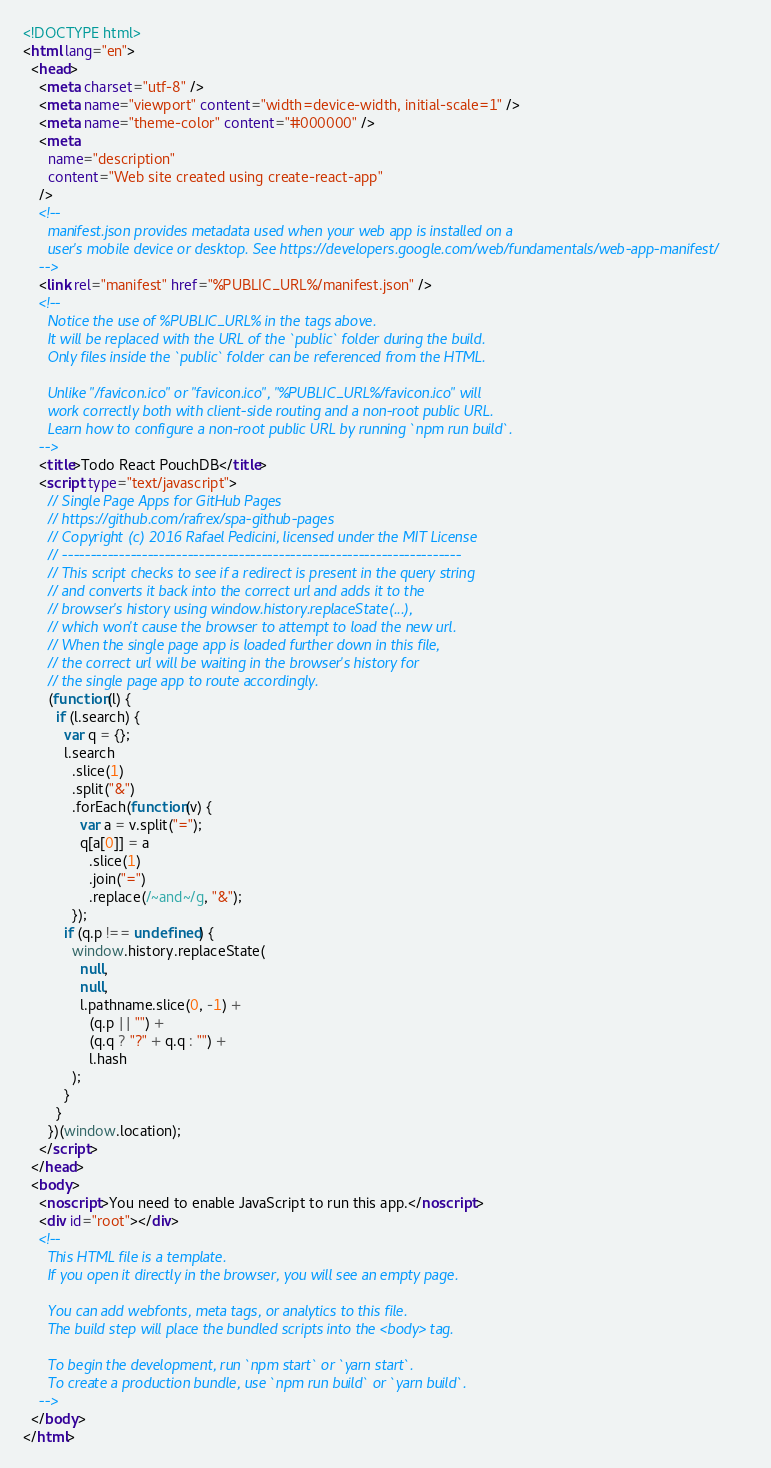Convert code to text. <code><loc_0><loc_0><loc_500><loc_500><_HTML_><!DOCTYPE html>
<html lang="en">
  <head>
    <meta charset="utf-8" />
    <meta name="viewport" content="width=device-width, initial-scale=1" />
    <meta name="theme-color" content="#000000" />
    <meta
      name="description"
      content="Web site created using create-react-app"
    />
    <!--
      manifest.json provides metadata used when your web app is installed on a
      user's mobile device or desktop. See https://developers.google.com/web/fundamentals/web-app-manifest/
    -->
    <link rel="manifest" href="%PUBLIC_URL%/manifest.json" />
    <!--
      Notice the use of %PUBLIC_URL% in the tags above.
      It will be replaced with the URL of the `public` folder during the build.
      Only files inside the `public` folder can be referenced from the HTML.

      Unlike "/favicon.ico" or "favicon.ico", "%PUBLIC_URL%/favicon.ico" will
      work correctly both with client-side routing and a non-root public URL.
      Learn how to configure a non-root public URL by running `npm run build`.
    -->
    <title>Todo React PouchDB</title>
    <script type="text/javascript">
      // Single Page Apps for GitHub Pages
      // https://github.com/rafrex/spa-github-pages
      // Copyright (c) 2016 Rafael Pedicini, licensed under the MIT License
      // ----------------------------------------------------------------------
      // This script checks to see if a redirect is present in the query string
      // and converts it back into the correct url and adds it to the
      // browser's history using window.history.replaceState(...),
      // which won't cause the browser to attempt to load the new url.
      // When the single page app is loaded further down in this file,
      // the correct url will be waiting in the browser's history for
      // the single page app to route accordingly.
      (function(l) {
        if (l.search) {
          var q = {};
          l.search
            .slice(1)
            .split("&")
            .forEach(function(v) {
              var a = v.split("=");
              q[a[0]] = a
                .slice(1)
                .join("=")
                .replace(/~and~/g, "&");
            });
          if (q.p !== undefined) {
            window.history.replaceState(
              null,
              null,
              l.pathname.slice(0, -1) +
                (q.p || "") +
                (q.q ? "?" + q.q : "") +
                l.hash
            );
          }
        }
      })(window.location);
    </script>
  </head>
  <body>
    <noscript>You need to enable JavaScript to run this app.</noscript>
    <div id="root"></div>
    <!--
      This HTML file is a template.
      If you open it directly in the browser, you will see an empty page.

      You can add webfonts, meta tags, or analytics to this file.
      The build step will place the bundled scripts into the <body> tag.

      To begin the development, run `npm start` or `yarn start`.
      To create a production bundle, use `npm run build` or `yarn build`.
    -->
  </body>
</html>
</code> 